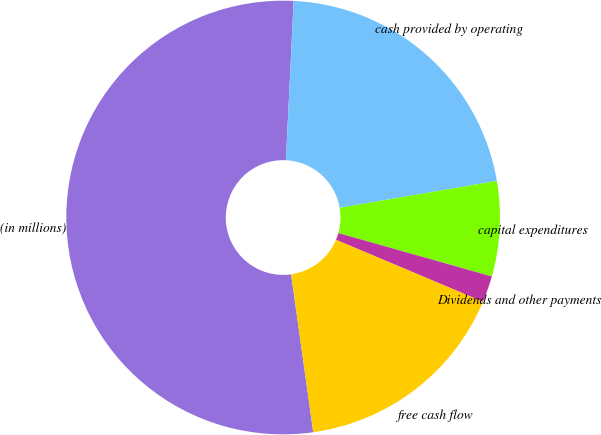Convert chart. <chart><loc_0><loc_0><loc_500><loc_500><pie_chart><fcel>(in millions)<fcel>cash provided by operating<fcel>capital expenditures<fcel>Dividends and other payments<fcel>free cash flow<nl><fcel>52.99%<fcel>21.53%<fcel>7.08%<fcel>1.97%<fcel>16.43%<nl></chart> 